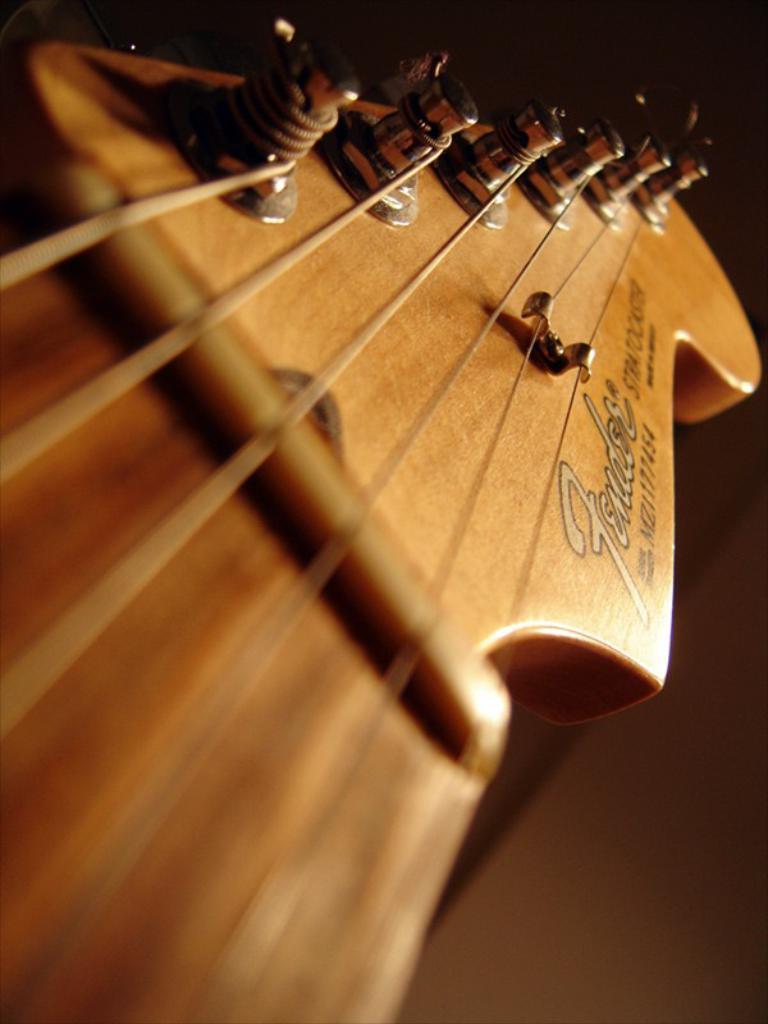Please provide a concise description of this image. These are strings of a guitar and the guitar is brown in color. 